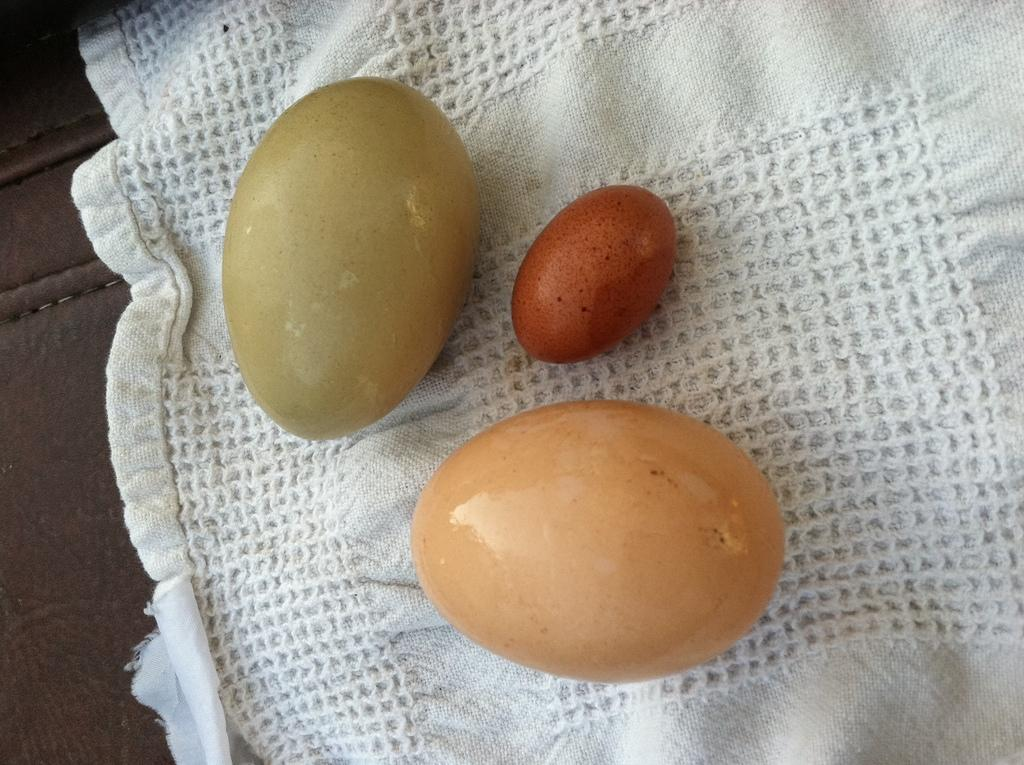How many eggs are visible in the image? There are three eggs in the image. What is the eggs placed on? The eggs are on a cloth. Where is the cloth located? The cloth is placed on a surface. What type of truck is visible in the image? There is no truck present in the image. Who is the writer in the image? There is no writer present in the image. 